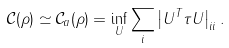<formula> <loc_0><loc_0><loc_500><loc_500>\mathcal { C } ( \rho ) \simeq \mathcal { C } _ { a } ( \rho ) = \inf _ { U } \sum _ { i } \left | U ^ { T } \tau U \right | _ { i i } .</formula> 